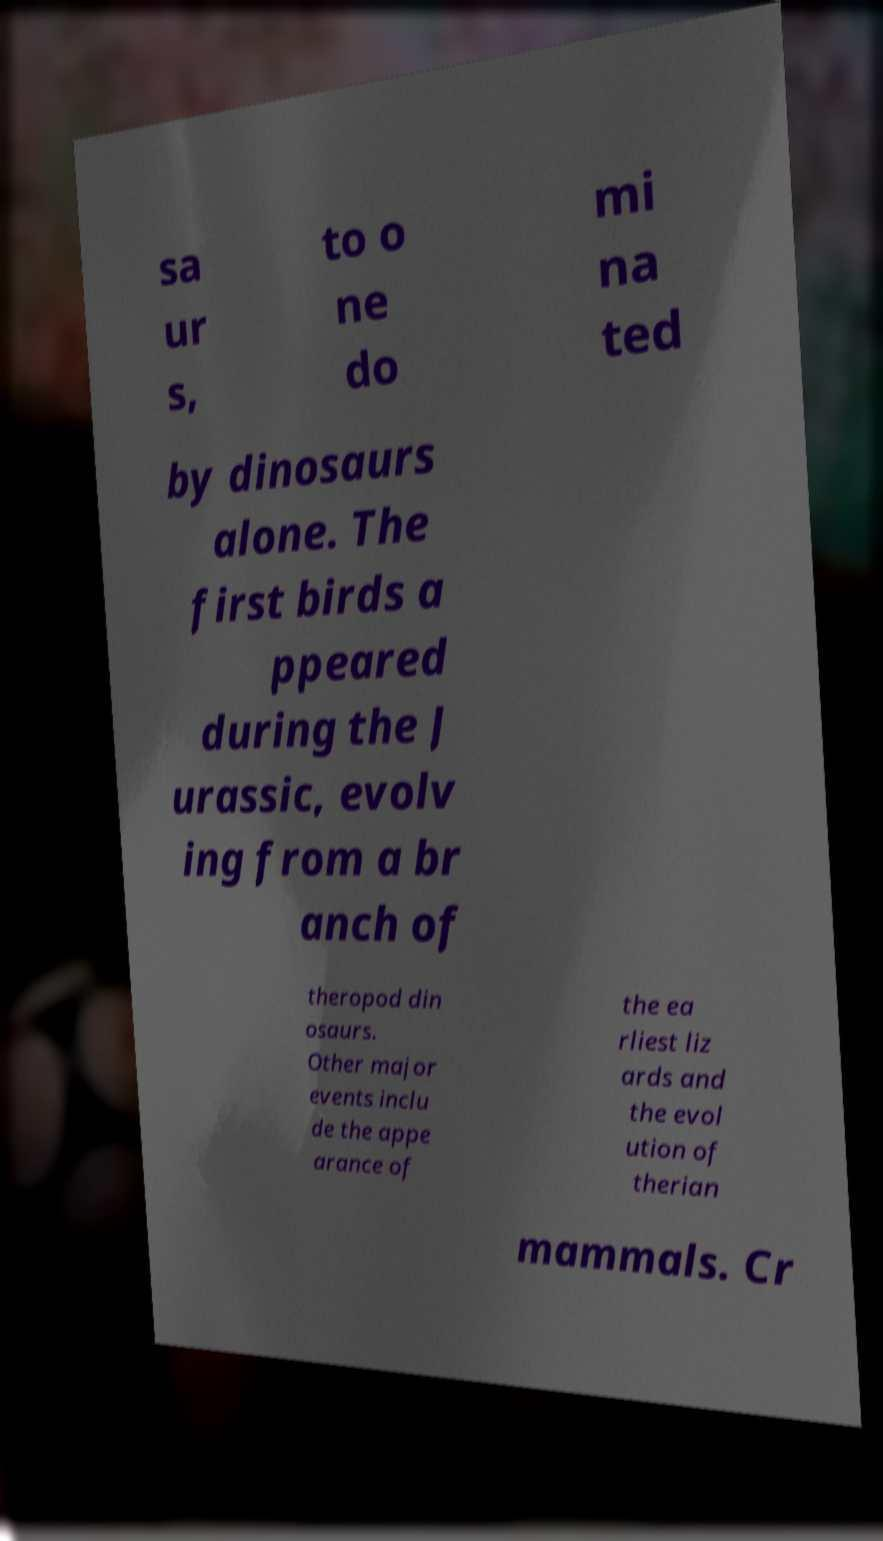I need the written content from this picture converted into text. Can you do that? sa ur s, to o ne do mi na ted by dinosaurs alone. The first birds a ppeared during the J urassic, evolv ing from a br anch of theropod din osaurs. Other major events inclu de the appe arance of the ea rliest liz ards and the evol ution of therian mammals. Cr 